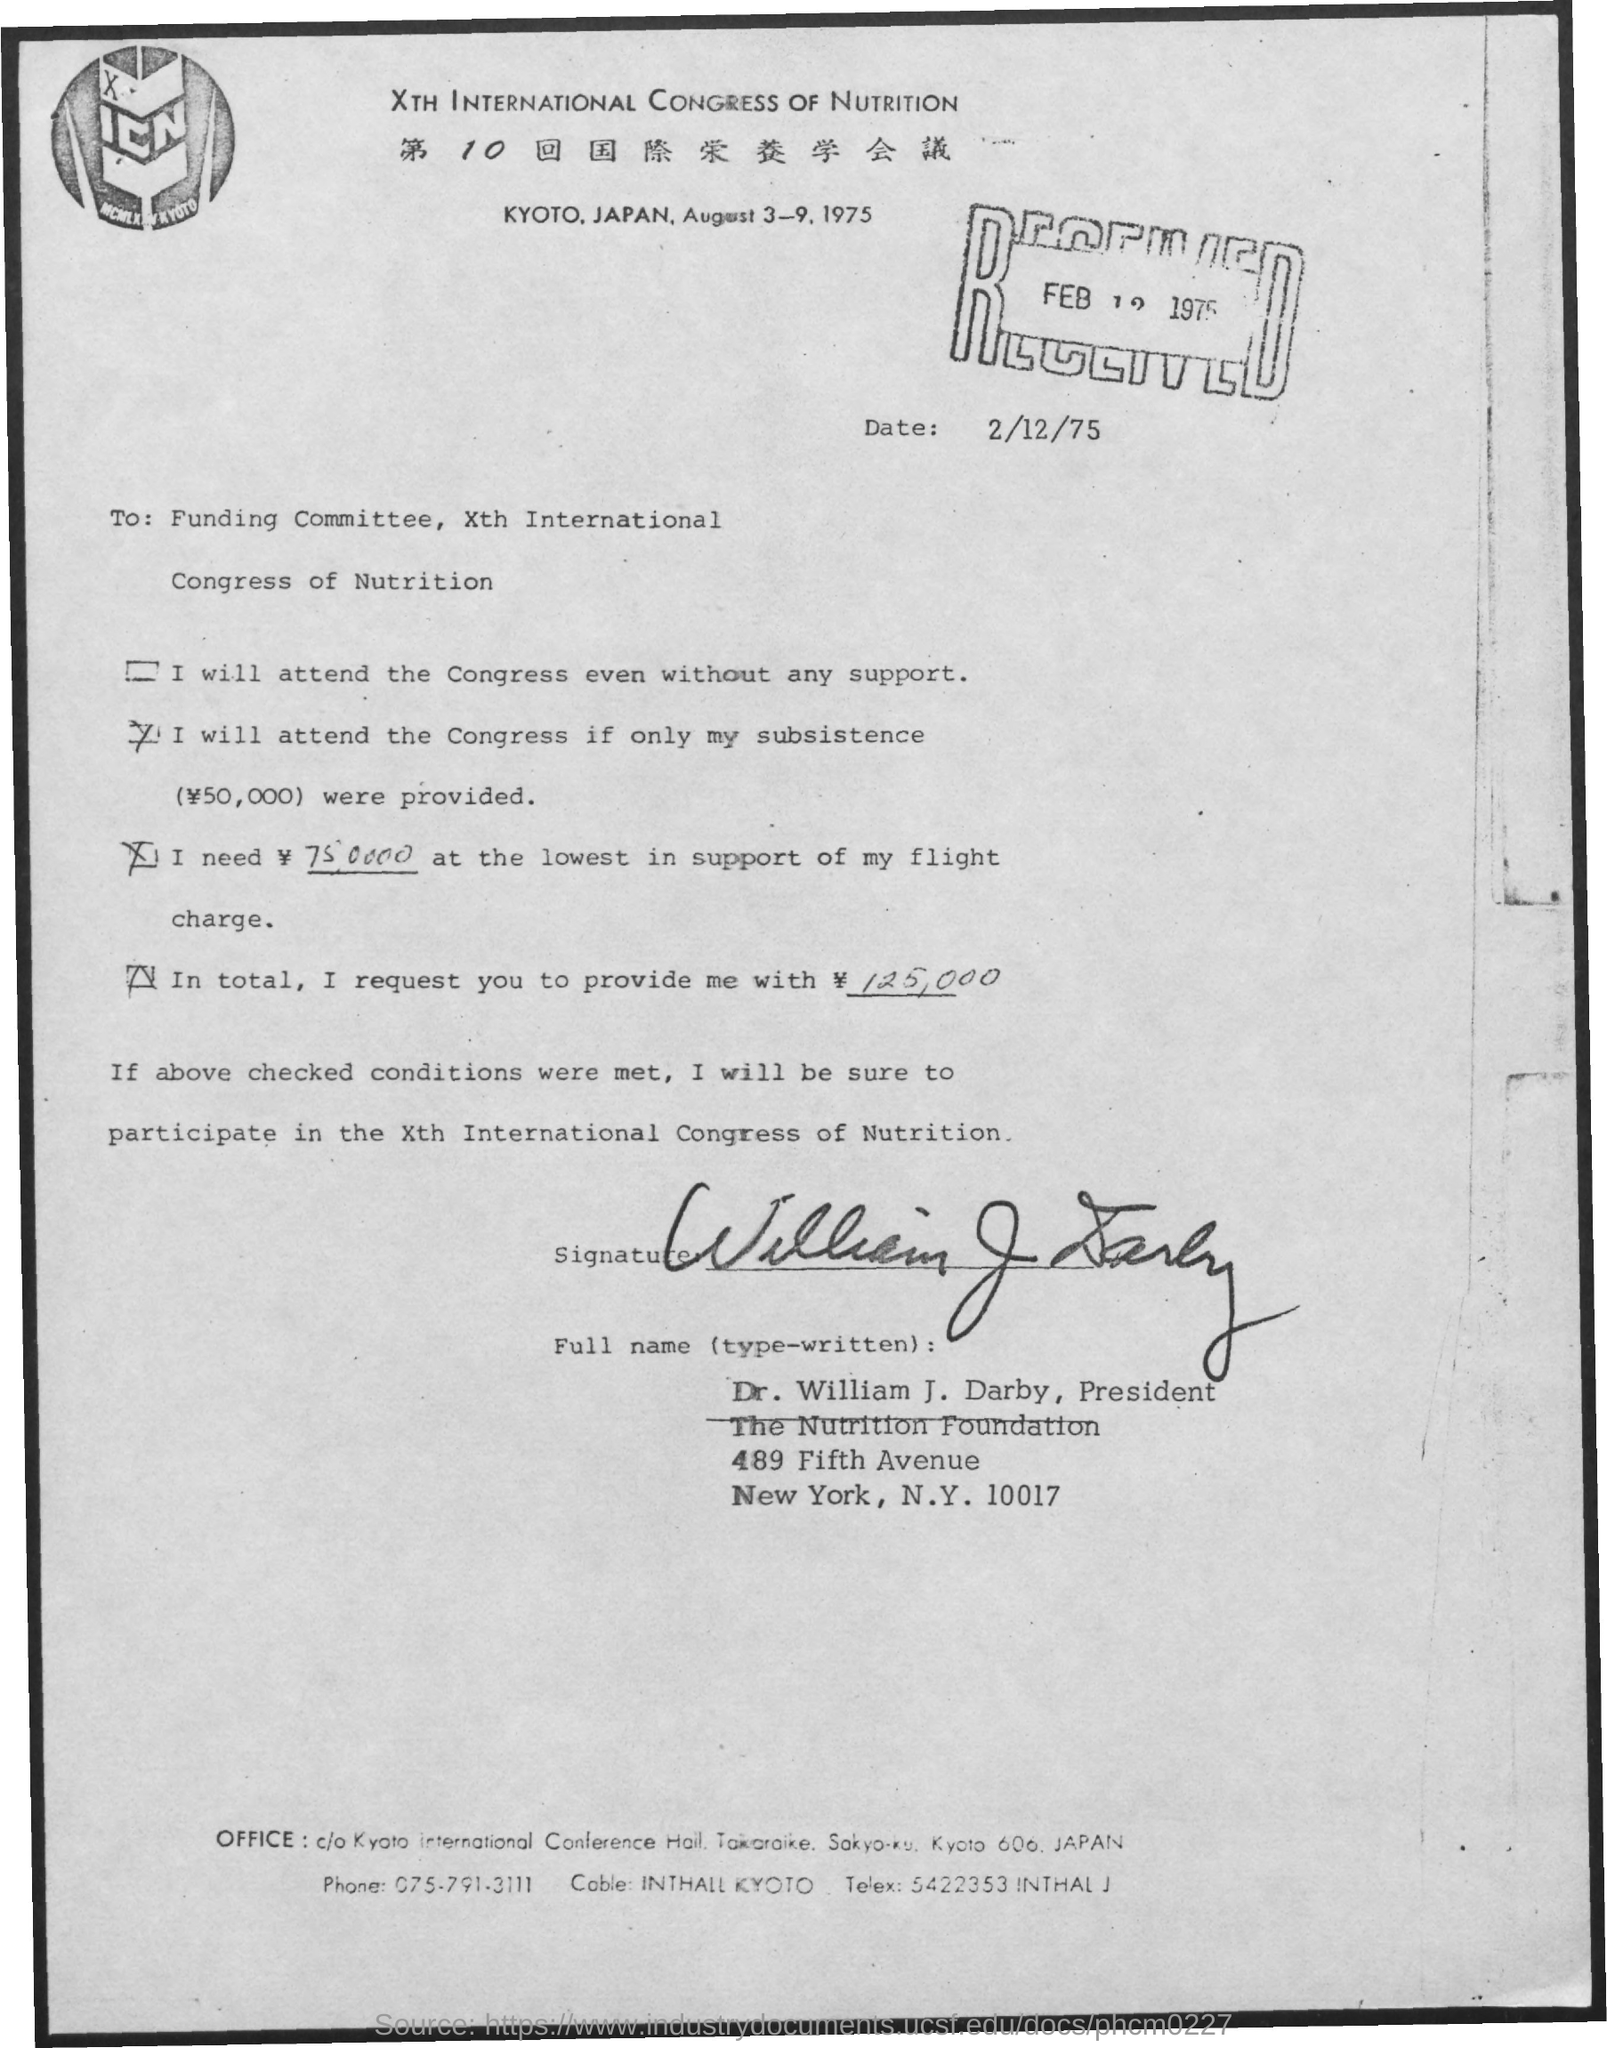Give some essential details in this illustration. The letter is addressed to the Funding Committee for the 10th International Congress of Nutrition. The Xth International Congress of Nutrition was held in order to address and explore the latest advances in the field of nutrition. The Congress will be held from August 3 to 9, 1975. It has been decided that the congress will be held in the city of Kyoto, Japan. The document is dated February 12, 1975. 